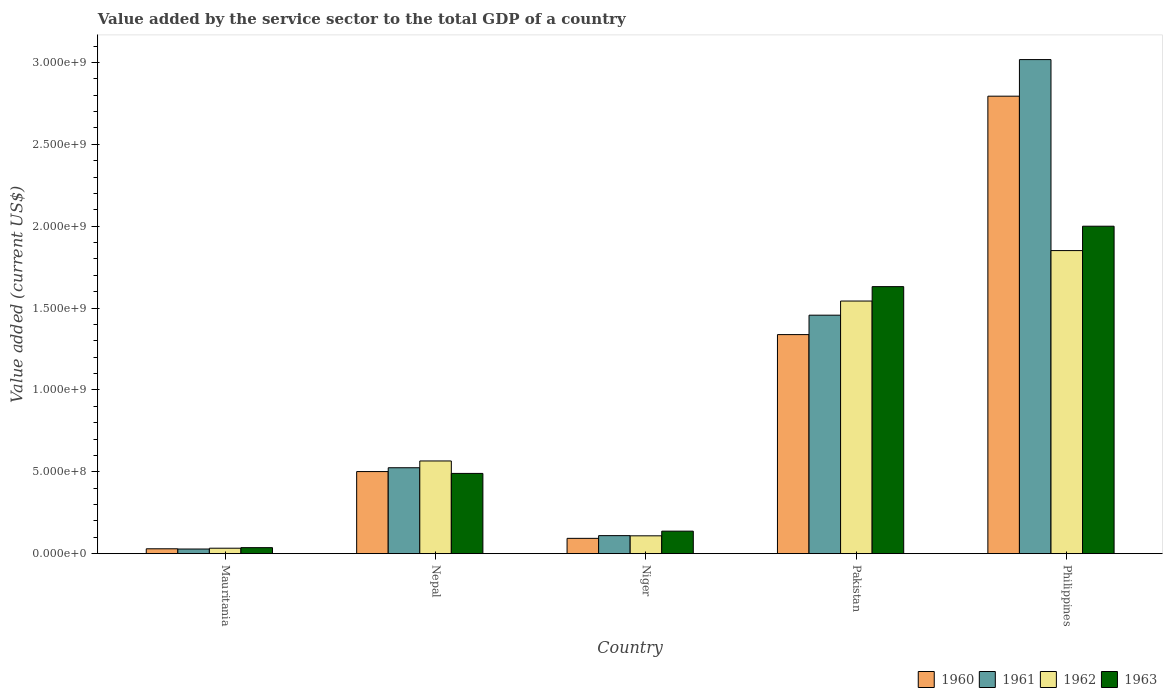How many bars are there on the 4th tick from the left?
Your answer should be very brief. 4. How many bars are there on the 4th tick from the right?
Give a very brief answer. 4. What is the label of the 1st group of bars from the left?
Offer a terse response. Mauritania. What is the value added by the service sector to the total GDP in 1960 in Mauritania?
Make the answer very short. 2.97e+07. Across all countries, what is the maximum value added by the service sector to the total GDP in 1961?
Provide a short and direct response. 3.02e+09. Across all countries, what is the minimum value added by the service sector to the total GDP in 1963?
Provide a succinct answer. 3.67e+07. In which country was the value added by the service sector to the total GDP in 1963 minimum?
Your response must be concise. Mauritania. What is the total value added by the service sector to the total GDP in 1963 in the graph?
Give a very brief answer. 4.29e+09. What is the difference between the value added by the service sector to the total GDP in 1962 in Mauritania and that in Nepal?
Give a very brief answer. -5.33e+08. What is the difference between the value added by the service sector to the total GDP in 1963 in Nepal and the value added by the service sector to the total GDP in 1961 in Niger?
Make the answer very short. 3.80e+08. What is the average value added by the service sector to the total GDP in 1962 per country?
Provide a succinct answer. 8.20e+08. What is the difference between the value added by the service sector to the total GDP of/in 1960 and value added by the service sector to the total GDP of/in 1962 in Philippines?
Ensure brevity in your answer.  9.43e+08. In how many countries, is the value added by the service sector to the total GDP in 1963 greater than 1900000000 US$?
Give a very brief answer. 1. What is the ratio of the value added by the service sector to the total GDP in 1962 in Nepal to that in Pakistan?
Offer a terse response. 0.37. What is the difference between the highest and the second highest value added by the service sector to the total GDP in 1963?
Offer a very short reply. -3.69e+08. What is the difference between the highest and the lowest value added by the service sector to the total GDP in 1961?
Make the answer very short. 2.99e+09. Is it the case that in every country, the sum of the value added by the service sector to the total GDP in 1960 and value added by the service sector to the total GDP in 1963 is greater than the sum of value added by the service sector to the total GDP in 1961 and value added by the service sector to the total GDP in 1962?
Offer a terse response. No. What does the 3rd bar from the left in Niger represents?
Provide a succinct answer. 1962. What does the 2nd bar from the right in Mauritania represents?
Provide a succinct answer. 1962. Is it the case that in every country, the sum of the value added by the service sector to the total GDP in 1961 and value added by the service sector to the total GDP in 1960 is greater than the value added by the service sector to the total GDP in 1963?
Make the answer very short. Yes. How many bars are there?
Give a very brief answer. 20. How many countries are there in the graph?
Offer a very short reply. 5. What is the difference between two consecutive major ticks on the Y-axis?
Your answer should be very brief. 5.00e+08. Does the graph contain any zero values?
Make the answer very short. No. How are the legend labels stacked?
Provide a succinct answer. Horizontal. What is the title of the graph?
Make the answer very short. Value added by the service sector to the total GDP of a country. What is the label or title of the Y-axis?
Provide a short and direct response. Value added (current US$). What is the Value added (current US$) of 1960 in Mauritania?
Provide a short and direct response. 2.97e+07. What is the Value added (current US$) in 1961 in Mauritania?
Give a very brief answer. 2.83e+07. What is the Value added (current US$) of 1962 in Mauritania?
Keep it short and to the point. 3.32e+07. What is the Value added (current US$) in 1963 in Mauritania?
Ensure brevity in your answer.  3.67e+07. What is the Value added (current US$) of 1960 in Nepal?
Keep it short and to the point. 5.01e+08. What is the Value added (current US$) of 1961 in Nepal?
Your response must be concise. 5.25e+08. What is the Value added (current US$) in 1962 in Nepal?
Offer a very short reply. 5.66e+08. What is the Value added (current US$) of 1963 in Nepal?
Provide a short and direct response. 4.90e+08. What is the Value added (current US$) in 1960 in Niger?
Your answer should be compact. 9.35e+07. What is the Value added (current US$) of 1961 in Niger?
Your answer should be very brief. 1.10e+08. What is the Value added (current US$) of 1962 in Niger?
Offer a very short reply. 1.09e+08. What is the Value added (current US$) of 1963 in Niger?
Your answer should be compact. 1.37e+08. What is the Value added (current US$) of 1960 in Pakistan?
Provide a short and direct response. 1.34e+09. What is the Value added (current US$) of 1961 in Pakistan?
Ensure brevity in your answer.  1.46e+09. What is the Value added (current US$) in 1962 in Pakistan?
Provide a succinct answer. 1.54e+09. What is the Value added (current US$) in 1963 in Pakistan?
Your answer should be very brief. 1.63e+09. What is the Value added (current US$) in 1960 in Philippines?
Your response must be concise. 2.79e+09. What is the Value added (current US$) of 1961 in Philippines?
Offer a very short reply. 3.02e+09. What is the Value added (current US$) of 1962 in Philippines?
Provide a short and direct response. 1.85e+09. What is the Value added (current US$) in 1963 in Philippines?
Give a very brief answer. 2.00e+09. Across all countries, what is the maximum Value added (current US$) of 1960?
Provide a short and direct response. 2.79e+09. Across all countries, what is the maximum Value added (current US$) in 1961?
Provide a succinct answer. 3.02e+09. Across all countries, what is the maximum Value added (current US$) in 1962?
Make the answer very short. 1.85e+09. Across all countries, what is the maximum Value added (current US$) of 1963?
Your answer should be compact. 2.00e+09. Across all countries, what is the minimum Value added (current US$) of 1960?
Keep it short and to the point. 2.97e+07. Across all countries, what is the minimum Value added (current US$) of 1961?
Offer a terse response. 2.83e+07. Across all countries, what is the minimum Value added (current US$) in 1962?
Provide a succinct answer. 3.32e+07. Across all countries, what is the minimum Value added (current US$) in 1963?
Offer a terse response. 3.67e+07. What is the total Value added (current US$) in 1960 in the graph?
Ensure brevity in your answer.  4.76e+09. What is the total Value added (current US$) of 1961 in the graph?
Your answer should be very brief. 5.14e+09. What is the total Value added (current US$) in 1962 in the graph?
Keep it short and to the point. 4.10e+09. What is the total Value added (current US$) in 1963 in the graph?
Make the answer very short. 4.29e+09. What is the difference between the Value added (current US$) in 1960 in Mauritania and that in Nepal?
Ensure brevity in your answer.  -4.72e+08. What is the difference between the Value added (current US$) of 1961 in Mauritania and that in Nepal?
Keep it short and to the point. -4.96e+08. What is the difference between the Value added (current US$) of 1962 in Mauritania and that in Nepal?
Your response must be concise. -5.33e+08. What is the difference between the Value added (current US$) of 1963 in Mauritania and that in Nepal?
Ensure brevity in your answer.  -4.53e+08. What is the difference between the Value added (current US$) of 1960 in Mauritania and that in Niger?
Make the answer very short. -6.37e+07. What is the difference between the Value added (current US$) in 1961 in Mauritania and that in Niger?
Your answer should be very brief. -8.18e+07. What is the difference between the Value added (current US$) in 1962 in Mauritania and that in Niger?
Keep it short and to the point. -7.57e+07. What is the difference between the Value added (current US$) in 1963 in Mauritania and that in Niger?
Make the answer very short. -1.01e+08. What is the difference between the Value added (current US$) of 1960 in Mauritania and that in Pakistan?
Keep it short and to the point. -1.31e+09. What is the difference between the Value added (current US$) of 1961 in Mauritania and that in Pakistan?
Offer a terse response. -1.43e+09. What is the difference between the Value added (current US$) in 1962 in Mauritania and that in Pakistan?
Offer a terse response. -1.51e+09. What is the difference between the Value added (current US$) of 1963 in Mauritania and that in Pakistan?
Your response must be concise. -1.59e+09. What is the difference between the Value added (current US$) of 1960 in Mauritania and that in Philippines?
Ensure brevity in your answer.  -2.76e+09. What is the difference between the Value added (current US$) in 1961 in Mauritania and that in Philippines?
Provide a short and direct response. -2.99e+09. What is the difference between the Value added (current US$) of 1962 in Mauritania and that in Philippines?
Ensure brevity in your answer.  -1.82e+09. What is the difference between the Value added (current US$) in 1963 in Mauritania and that in Philippines?
Keep it short and to the point. -1.96e+09. What is the difference between the Value added (current US$) in 1960 in Nepal and that in Niger?
Your response must be concise. 4.08e+08. What is the difference between the Value added (current US$) of 1961 in Nepal and that in Niger?
Ensure brevity in your answer.  4.14e+08. What is the difference between the Value added (current US$) in 1962 in Nepal and that in Niger?
Offer a terse response. 4.57e+08. What is the difference between the Value added (current US$) of 1963 in Nepal and that in Niger?
Give a very brief answer. 3.53e+08. What is the difference between the Value added (current US$) of 1960 in Nepal and that in Pakistan?
Offer a terse response. -8.36e+08. What is the difference between the Value added (current US$) of 1961 in Nepal and that in Pakistan?
Provide a succinct answer. -9.32e+08. What is the difference between the Value added (current US$) of 1962 in Nepal and that in Pakistan?
Make the answer very short. -9.77e+08. What is the difference between the Value added (current US$) of 1963 in Nepal and that in Pakistan?
Keep it short and to the point. -1.14e+09. What is the difference between the Value added (current US$) in 1960 in Nepal and that in Philippines?
Make the answer very short. -2.29e+09. What is the difference between the Value added (current US$) of 1961 in Nepal and that in Philippines?
Provide a succinct answer. -2.49e+09. What is the difference between the Value added (current US$) in 1962 in Nepal and that in Philippines?
Make the answer very short. -1.28e+09. What is the difference between the Value added (current US$) in 1963 in Nepal and that in Philippines?
Your answer should be very brief. -1.51e+09. What is the difference between the Value added (current US$) in 1960 in Niger and that in Pakistan?
Offer a very short reply. -1.24e+09. What is the difference between the Value added (current US$) in 1961 in Niger and that in Pakistan?
Provide a succinct answer. -1.35e+09. What is the difference between the Value added (current US$) in 1962 in Niger and that in Pakistan?
Your answer should be very brief. -1.43e+09. What is the difference between the Value added (current US$) of 1963 in Niger and that in Pakistan?
Give a very brief answer. -1.49e+09. What is the difference between the Value added (current US$) of 1960 in Niger and that in Philippines?
Make the answer very short. -2.70e+09. What is the difference between the Value added (current US$) of 1961 in Niger and that in Philippines?
Ensure brevity in your answer.  -2.91e+09. What is the difference between the Value added (current US$) in 1962 in Niger and that in Philippines?
Give a very brief answer. -1.74e+09. What is the difference between the Value added (current US$) in 1963 in Niger and that in Philippines?
Offer a terse response. -1.86e+09. What is the difference between the Value added (current US$) in 1960 in Pakistan and that in Philippines?
Give a very brief answer. -1.46e+09. What is the difference between the Value added (current US$) of 1961 in Pakistan and that in Philippines?
Your answer should be very brief. -1.56e+09. What is the difference between the Value added (current US$) in 1962 in Pakistan and that in Philippines?
Your answer should be very brief. -3.08e+08. What is the difference between the Value added (current US$) in 1963 in Pakistan and that in Philippines?
Offer a very short reply. -3.69e+08. What is the difference between the Value added (current US$) in 1960 in Mauritania and the Value added (current US$) in 1961 in Nepal?
Your answer should be very brief. -4.95e+08. What is the difference between the Value added (current US$) in 1960 in Mauritania and the Value added (current US$) in 1962 in Nepal?
Your answer should be very brief. -5.36e+08. What is the difference between the Value added (current US$) in 1960 in Mauritania and the Value added (current US$) in 1963 in Nepal?
Provide a short and direct response. -4.60e+08. What is the difference between the Value added (current US$) of 1961 in Mauritania and the Value added (current US$) of 1962 in Nepal?
Offer a very short reply. -5.38e+08. What is the difference between the Value added (current US$) of 1961 in Mauritania and the Value added (current US$) of 1963 in Nepal?
Keep it short and to the point. -4.62e+08. What is the difference between the Value added (current US$) of 1962 in Mauritania and the Value added (current US$) of 1963 in Nepal?
Ensure brevity in your answer.  -4.57e+08. What is the difference between the Value added (current US$) in 1960 in Mauritania and the Value added (current US$) in 1961 in Niger?
Offer a terse response. -8.04e+07. What is the difference between the Value added (current US$) in 1960 in Mauritania and the Value added (current US$) in 1962 in Niger?
Provide a succinct answer. -7.92e+07. What is the difference between the Value added (current US$) of 1960 in Mauritania and the Value added (current US$) of 1963 in Niger?
Your answer should be compact. -1.08e+08. What is the difference between the Value added (current US$) of 1961 in Mauritania and the Value added (current US$) of 1962 in Niger?
Offer a very short reply. -8.06e+07. What is the difference between the Value added (current US$) in 1961 in Mauritania and the Value added (current US$) in 1963 in Niger?
Provide a succinct answer. -1.09e+08. What is the difference between the Value added (current US$) of 1962 in Mauritania and the Value added (current US$) of 1963 in Niger?
Keep it short and to the point. -1.04e+08. What is the difference between the Value added (current US$) of 1960 in Mauritania and the Value added (current US$) of 1961 in Pakistan?
Your response must be concise. -1.43e+09. What is the difference between the Value added (current US$) of 1960 in Mauritania and the Value added (current US$) of 1962 in Pakistan?
Keep it short and to the point. -1.51e+09. What is the difference between the Value added (current US$) in 1960 in Mauritania and the Value added (current US$) in 1963 in Pakistan?
Your answer should be very brief. -1.60e+09. What is the difference between the Value added (current US$) in 1961 in Mauritania and the Value added (current US$) in 1962 in Pakistan?
Your answer should be compact. -1.51e+09. What is the difference between the Value added (current US$) of 1961 in Mauritania and the Value added (current US$) of 1963 in Pakistan?
Your response must be concise. -1.60e+09. What is the difference between the Value added (current US$) of 1962 in Mauritania and the Value added (current US$) of 1963 in Pakistan?
Provide a short and direct response. -1.60e+09. What is the difference between the Value added (current US$) of 1960 in Mauritania and the Value added (current US$) of 1961 in Philippines?
Provide a short and direct response. -2.99e+09. What is the difference between the Value added (current US$) in 1960 in Mauritania and the Value added (current US$) in 1962 in Philippines?
Your answer should be very brief. -1.82e+09. What is the difference between the Value added (current US$) of 1960 in Mauritania and the Value added (current US$) of 1963 in Philippines?
Give a very brief answer. -1.97e+09. What is the difference between the Value added (current US$) of 1961 in Mauritania and the Value added (current US$) of 1962 in Philippines?
Your response must be concise. -1.82e+09. What is the difference between the Value added (current US$) of 1961 in Mauritania and the Value added (current US$) of 1963 in Philippines?
Offer a very short reply. -1.97e+09. What is the difference between the Value added (current US$) of 1962 in Mauritania and the Value added (current US$) of 1963 in Philippines?
Your answer should be very brief. -1.97e+09. What is the difference between the Value added (current US$) of 1960 in Nepal and the Value added (current US$) of 1961 in Niger?
Your answer should be very brief. 3.91e+08. What is the difference between the Value added (current US$) in 1960 in Nepal and the Value added (current US$) in 1962 in Niger?
Offer a terse response. 3.92e+08. What is the difference between the Value added (current US$) in 1960 in Nepal and the Value added (current US$) in 1963 in Niger?
Offer a very short reply. 3.64e+08. What is the difference between the Value added (current US$) of 1961 in Nepal and the Value added (current US$) of 1962 in Niger?
Your answer should be very brief. 4.16e+08. What is the difference between the Value added (current US$) in 1961 in Nepal and the Value added (current US$) in 1963 in Niger?
Give a very brief answer. 3.87e+08. What is the difference between the Value added (current US$) of 1962 in Nepal and the Value added (current US$) of 1963 in Niger?
Your answer should be very brief. 4.29e+08. What is the difference between the Value added (current US$) of 1960 in Nepal and the Value added (current US$) of 1961 in Pakistan?
Provide a short and direct response. -9.55e+08. What is the difference between the Value added (current US$) of 1960 in Nepal and the Value added (current US$) of 1962 in Pakistan?
Your answer should be very brief. -1.04e+09. What is the difference between the Value added (current US$) of 1960 in Nepal and the Value added (current US$) of 1963 in Pakistan?
Provide a short and direct response. -1.13e+09. What is the difference between the Value added (current US$) of 1961 in Nepal and the Value added (current US$) of 1962 in Pakistan?
Give a very brief answer. -1.02e+09. What is the difference between the Value added (current US$) in 1961 in Nepal and the Value added (current US$) in 1963 in Pakistan?
Ensure brevity in your answer.  -1.11e+09. What is the difference between the Value added (current US$) in 1962 in Nepal and the Value added (current US$) in 1963 in Pakistan?
Provide a succinct answer. -1.06e+09. What is the difference between the Value added (current US$) of 1960 in Nepal and the Value added (current US$) of 1961 in Philippines?
Keep it short and to the point. -2.52e+09. What is the difference between the Value added (current US$) in 1960 in Nepal and the Value added (current US$) in 1962 in Philippines?
Make the answer very short. -1.35e+09. What is the difference between the Value added (current US$) in 1960 in Nepal and the Value added (current US$) in 1963 in Philippines?
Provide a succinct answer. -1.50e+09. What is the difference between the Value added (current US$) in 1961 in Nepal and the Value added (current US$) in 1962 in Philippines?
Your answer should be compact. -1.33e+09. What is the difference between the Value added (current US$) of 1961 in Nepal and the Value added (current US$) of 1963 in Philippines?
Keep it short and to the point. -1.47e+09. What is the difference between the Value added (current US$) in 1962 in Nepal and the Value added (current US$) in 1963 in Philippines?
Make the answer very short. -1.43e+09. What is the difference between the Value added (current US$) of 1960 in Niger and the Value added (current US$) of 1961 in Pakistan?
Your response must be concise. -1.36e+09. What is the difference between the Value added (current US$) in 1960 in Niger and the Value added (current US$) in 1962 in Pakistan?
Keep it short and to the point. -1.45e+09. What is the difference between the Value added (current US$) in 1960 in Niger and the Value added (current US$) in 1963 in Pakistan?
Offer a terse response. -1.54e+09. What is the difference between the Value added (current US$) of 1961 in Niger and the Value added (current US$) of 1962 in Pakistan?
Make the answer very short. -1.43e+09. What is the difference between the Value added (current US$) in 1961 in Niger and the Value added (current US$) in 1963 in Pakistan?
Your answer should be compact. -1.52e+09. What is the difference between the Value added (current US$) of 1962 in Niger and the Value added (current US$) of 1963 in Pakistan?
Keep it short and to the point. -1.52e+09. What is the difference between the Value added (current US$) of 1960 in Niger and the Value added (current US$) of 1961 in Philippines?
Provide a short and direct response. -2.92e+09. What is the difference between the Value added (current US$) in 1960 in Niger and the Value added (current US$) in 1962 in Philippines?
Keep it short and to the point. -1.76e+09. What is the difference between the Value added (current US$) of 1960 in Niger and the Value added (current US$) of 1963 in Philippines?
Keep it short and to the point. -1.91e+09. What is the difference between the Value added (current US$) of 1961 in Niger and the Value added (current US$) of 1962 in Philippines?
Ensure brevity in your answer.  -1.74e+09. What is the difference between the Value added (current US$) in 1961 in Niger and the Value added (current US$) in 1963 in Philippines?
Keep it short and to the point. -1.89e+09. What is the difference between the Value added (current US$) in 1962 in Niger and the Value added (current US$) in 1963 in Philippines?
Your answer should be compact. -1.89e+09. What is the difference between the Value added (current US$) in 1960 in Pakistan and the Value added (current US$) in 1961 in Philippines?
Keep it short and to the point. -1.68e+09. What is the difference between the Value added (current US$) in 1960 in Pakistan and the Value added (current US$) in 1962 in Philippines?
Your response must be concise. -5.13e+08. What is the difference between the Value added (current US$) of 1960 in Pakistan and the Value added (current US$) of 1963 in Philippines?
Your answer should be very brief. -6.62e+08. What is the difference between the Value added (current US$) in 1961 in Pakistan and the Value added (current US$) in 1962 in Philippines?
Offer a terse response. -3.94e+08. What is the difference between the Value added (current US$) in 1961 in Pakistan and the Value added (current US$) in 1963 in Philippines?
Ensure brevity in your answer.  -5.43e+08. What is the difference between the Value added (current US$) in 1962 in Pakistan and the Value added (current US$) in 1963 in Philippines?
Keep it short and to the point. -4.57e+08. What is the average Value added (current US$) in 1960 per country?
Make the answer very short. 9.51e+08. What is the average Value added (current US$) of 1961 per country?
Your answer should be very brief. 1.03e+09. What is the average Value added (current US$) in 1962 per country?
Your response must be concise. 8.20e+08. What is the average Value added (current US$) in 1963 per country?
Make the answer very short. 8.59e+08. What is the difference between the Value added (current US$) in 1960 and Value added (current US$) in 1961 in Mauritania?
Provide a succinct answer. 1.42e+06. What is the difference between the Value added (current US$) of 1960 and Value added (current US$) of 1962 in Mauritania?
Ensure brevity in your answer.  -3.51e+06. What is the difference between the Value added (current US$) of 1960 and Value added (current US$) of 1963 in Mauritania?
Provide a short and direct response. -6.94e+06. What is the difference between the Value added (current US$) in 1961 and Value added (current US$) in 1962 in Mauritania?
Ensure brevity in your answer.  -4.93e+06. What is the difference between the Value added (current US$) in 1961 and Value added (current US$) in 1963 in Mauritania?
Provide a short and direct response. -8.35e+06. What is the difference between the Value added (current US$) of 1962 and Value added (current US$) of 1963 in Mauritania?
Your response must be concise. -3.42e+06. What is the difference between the Value added (current US$) of 1960 and Value added (current US$) of 1961 in Nepal?
Offer a terse response. -2.34e+07. What is the difference between the Value added (current US$) in 1960 and Value added (current US$) in 1962 in Nepal?
Keep it short and to the point. -6.48e+07. What is the difference between the Value added (current US$) of 1960 and Value added (current US$) of 1963 in Nepal?
Make the answer very short. 1.12e+07. What is the difference between the Value added (current US$) in 1961 and Value added (current US$) in 1962 in Nepal?
Ensure brevity in your answer.  -4.15e+07. What is the difference between the Value added (current US$) in 1961 and Value added (current US$) in 1963 in Nepal?
Your response must be concise. 3.46e+07. What is the difference between the Value added (current US$) of 1962 and Value added (current US$) of 1963 in Nepal?
Offer a terse response. 7.60e+07. What is the difference between the Value added (current US$) in 1960 and Value added (current US$) in 1961 in Niger?
Keep it short and to the point. -1.67e+07. What is the difference between the Value added (current US$) of 1960 and Value added (current US$) of 1962 in Niger?
Your answer should be very brief. -1.55e+07. What is the difference between the Value added (current US$) of 1960 and Value added (current US$) of 1963 in Niger?
Provide a short and direct response. -4.40e+07. What is the difference between the Value added (current US$) in 1961 and Value added (current US$) in 1962 in Niger?
Ensure brevity in your answer.  1.20e+06. What is the difference between the Value added (current US$) in 1961 and Value added (current US$) in 1963 in Niger?
Your answer should be compact. -2.73e+07. What is the difference between the Value added (current US$) in 1962 and Value added (current US$) in 1963 in Niger?
Make the answer very short. -2.85e+07. What is the difference between the Value added (current US$) of 1960 and Value added (current US$) of 1961 in Pakistan?
Your answer should be very brief. -1.19e+08. What is the difference between the Value added (current US$) in 1960 and Value added (current US$) in 1962 in Pakistan?
Your answer should be very brief. -2.05e+08. What is the difference between the Value added (current US$) in 1960 and Value added (current US$) in 1963 in Pakistan?
Offer a very short reply. -2.93e+08. What is the difference between the Value added (current US$) in 1961 and Value added (current US$) in 1962 in Pakistan?
Provide a succinct answer. -8.63e+07. What is the difference between the Value added (current US$) of 1961 and Value added (current US$) of 1963 in Pakistan?
Offer a very short reply. -1.74e+08. What is the difference between the Value added (current US$) in 1962 and Value added (current US$) in 1963 in Pakistan?
Provide a short and direct response. -8.80e+07. What is the difference between the Value added (current US$) of 1960 and Value added (current US$) of 1961 in Philippines?
Provide a succinct answer. -2.24e+08. What is the difference between the Value added (current US$) of 1960 and Value added (current US$) of 1962 in Philippines?
Provide a succinct answer. 9.43e+08. What is the difference between the Value added (current US$) of 1960 and Value added (current US$) of 1963 in Philippines?
Provide a succinct answer. 7.94e+08. What is the difference between the Value added (current US$) of 1961 and Value added (current US$) of 1962 in Philippines?
Provide a short and direct response. 1.17e+09. What is the difference between the Value added (current US$) of 1961 and Value added (current US$) of 1963 in Philippines?
Your answer should be compact. 1.02e+09. What is the difference between the Value added (current US$) in 1962 and Value added (current US$) in 1963 in Philippines?
Your response must be concise. -1.49e+08. What is the ratio of the Value added (current US$) of 1960 in Mauritania to that in Nepal?
Your answer should be very brief. 0.06. What is the ratio of the Value added (current US$) in 1961 in Mauritania to that in Nepal?
Keep it short and to the point. 0.05. What is the ratio of the Value added (current US$) in 1962 in Mauritania to that in Nepal?
Provide a succinct answer. 0.06. What is the ratio of the Value added (current US$) of 1963 in Mauritania to that in Nepal?
Give a very brief answer. 0.07. What is the ratio of the Value added (current US$) of 1960 in Mauritania to that in Niger?
Make the answer very short. 0.32. What is the ratio of the Value added (current US$) in 1961 in Mauritania to that in Niger?
Your response must be concise. 0.26. What is the ratio of the Value added (current US$) of 1962 in Mauritania to that in Niger?
Offer a terse response. 0.31. What is the ratio of the Value added (current US$) of 1963 in Mauritania to that in Niger?
Offer a very short reply. 0.27. What is the ratio of the Value added (current US$) in 1960 in Mauritania to that in Pakistan?
Provide a short and direct response. 0.02. What is the ratio of the Value added (current US$) in 1961 in Mauritania to that in Pakistan?
Your answer should be compact. 0.02. What is the ratio of the Value added (current US$) of 1962 in Mauritania to that in Pakistan?
Provide a short and direct response. 0.02. What is the ratio of the Value added (current US$) in 1963 in Mauritania to that in Pakistan?
Make the answer very short. 0.02. What is the ratio of the Value added (current US$) in 1960 in Mauritania to that in Philippines?
Offer a very short reply. 0.01. What is the ratio of the Value added (current US$) of 1961 in Mauritania to that in Philippines?
Ensure brevity in your answer.  0.01. What is the ratio of the Value added (current US$) of 1962 in Mauritania to that in Philippines?
Give a very brief answer. 0.02. What is the ratio of the Value added (current US$) of 1963 in Mauritania to that in Philippines?
Offer a very short reply. 0.02. What is the ratio of the Value added (current US$) in 1960 in Nepal to that in Niger?
Provide a short and direct response. 5.36. What is the ratio of the Value added (current US$) of 1961 in Nepal to that in Niger?
Offer a terse response. 4.76. What is the ratio of the Value added (current US$) of 1962 in Nepal to that in Niger?
Offer a terse response. 5.2. What is the ratio of the Value added (current US$) in 1963 in Nepal to that in Niger?
Provide a short and direct response. 3.57. What is the ratio of the Value added (current US$) in 1960 in Nepal to that in Pakistan?
Give a very brief answer. 0.37. What is the ratio of the Value added (current US$) of 1961 in Nepal to that in Pakistan?
Provide a short and direct response. 0.36. What is the ratio of the Value added (current US$) of 1962 in Nepal to that in Pakistan?
Provide a succinct answer. 0.37. What is the ratio of the Value added (current US$) in 1963 in Nepal to that in Pakistan?
Give a very brief answer. 0.3. What is the ratio of the Value added (current US$) in 1960 in Nepal to that in Philippines?
Provide a short and direct response. 0.18. What is the ratio of the Value added (current US$) of 1961 in Nepal to that in Philippines?
Offer a terse response. 0.17. What is the ratio of the Value added (current US$) of 1962 in Nepal to that in Philippines?
Your answer should be compact. 0.31. What is the ratio of the Value added (current US$) of 1963 in Nepal to that in Philippines?
Your answer should be compact. 0.25. What is the ratio of the Value added (current US$) of 1960 in Niger to that in Pakistan?
Keep it short and to the point. 0.07. What is the ratio of the Value added (current US$) of 1961 in Niger to that in Pakistan?
Keep it short and to the point. 0.08. What is the ratio of the Value added (current US$) in 1962 in Niger to that in Pakistan?
Your answer should be compact. 0.07. What is the ratio of the Value added (current US$) in 1963 in Niger to that in Pakistan?
Provide a short and direct response. 0.08. What is the ratio of the Value added (current US$) in 1960 in Niger to that in Philippines?
Your answer should be compact. 0.03. What is the ratio of the Value added (current US$) in 1961 in Niger to that in Philippines?
Offer a very short reply. 0.04. What is the ratio of the Value added (current US$) in 1962 in Niger to that in Philippines?
Your response must be concise. 0.06. What is the ratio of the Value added (current US$) of 1963 in Niger to that in Philippines?
Keep it short and to the point. 0.07. What is the ratio of the Value added (current US$) of 1960 in Pakistan to that in Philippines?
Offer a terse response. 0.48. What is the ratio of the Value added (current US$) of 1961 in Pakistan to that in Philippines?
Make the answer very short. 0.48. What is the ratio of the Value added (current US$) in 1962 in Pakistan to that in Philippines?
Keep it short and to the point. 0.83. What is the ratio of the Value added (current US$) in 1963 in Pakistan to that in Philippines?
Offer a very short reply. 0.82. What is the difference between the highest and the second highest Value added (current US$) of 1960?
Provide a succinct answer. 1.46e+09. What is the difference between the highest and the second highest Value added (current US$) in 1961?
Keep it short and to the point. 1.56e+09. What is the difference between the highest and the second highest Value added (current US$) in 1962?
Keep it short and to the point. 3.08e+08. What is the difference between the highest and the second highest Value added (current US$) in 1963?
Give a very brief answer. 3.69e+08. What is the difference between the highest and the lowest Value added (current US$) in 1960?
Your answer should be compact. 2.76e+09. What is the difference between the highest and the lowest Value added (current US$) of 1961?
Your answer should be compact. 2.99e+09. What is the difference between the highest and the lowest Value added (current US$) of 1962?
Ensure brevity in your answer.  1.82e+09. What is the difference between the highest and the lowest Value added (current US$) in 1963?
Ensure brevity in your answer.  1.96e+09. 